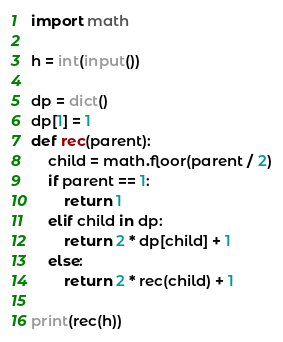<code> <loc_0><loc_0><loc_500><loc_500><_Python_>import math

h = int(input())

dp = dict()
dp[1] = 1
def rec(parent):
    child = math.floor(parent / 2)
    if parent == 1:
        return 1
    elif child in dp:
        return 2 * dp[child] + 1
    else:
        return 2 * rec(child) + 1

print(rec(h))</code> 